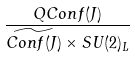Convert formula to latex. <formula><loc_0><loc_0><loc_500><loc_500>\frac { Q C o n f ( J ) } { \widetilde { C o n f ( J ) } \times S U ( 2 ) _ { L } }</formula> 